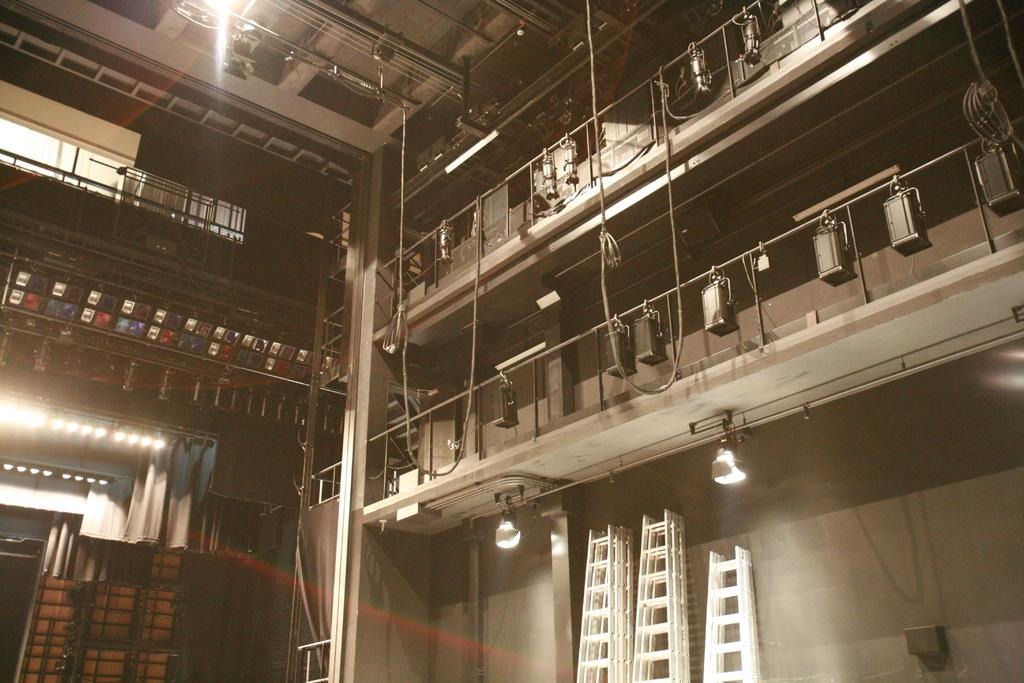What type of location is shown in the image? The image depicts the interior of a building. Can you describe any objects that are present in the interior? Unfortunately, the provided facts do not specify any objects present in the interior. What type of magic is being performed in the image? There is no magic present in the image; it depicts the interior of a building with unspecified objects. 